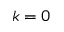<formula> <loc_0><loc_0><loc_500><loc_500>k = 0</formula> 